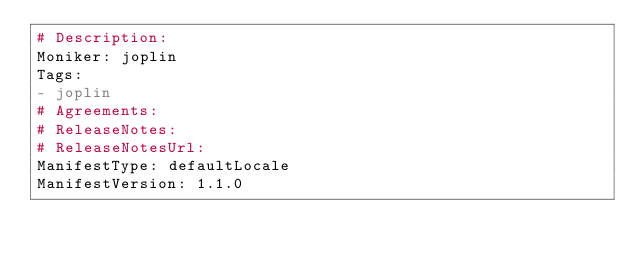Convert code to text. <code><loc_0><loc_0><loc_500><loc_500><_YAML_># Description: 
Moniker: joplin
Tags:
- joplin
# Agreements: 
# ReleaseNotes: 
# ReleaseNotesUrl: 
ManifestType: defaultLocale
ManifestVersion: 1.1.0
</code> 